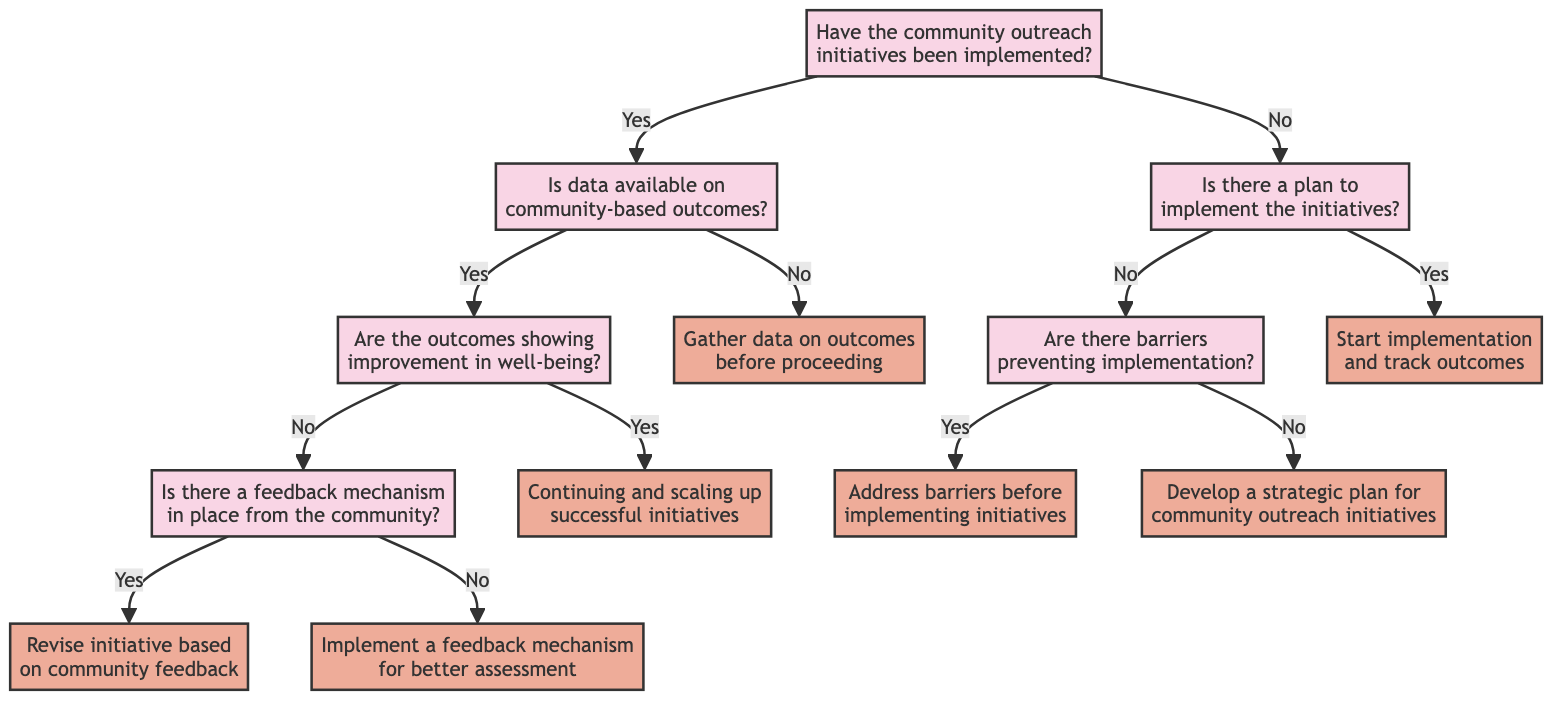What is the first question asked in the decision tree? The first question in the decision tree is "Have the community outreach initiatives been implemented?" which is the starting point of the flow.
Answer: Have the community outreach initiatives been implemented? How many endpoints are there in the decision tree? By examining the diagram, we see there are six endpoints: "Continuing and scaling up successful initiatives," "Revise initiative based on community feedback," "Implement a feedback mechanism for better assessment," "Gather data on outcomes before proceeding," "Start implementation and track outcomes," and "Address barriers before implementing initiatives." Counting them gives a total of six.
Answer: Six What happens if the community outreach initiatives have not been implemented? If the community outreach initiatives have not been implemented, the next question asked is "Is there a plan to implement the initiatives?" leading to further pathways based on the answer.
Answer: Is there a plan to implement the initiatives? If there is feedback from the community but outcomes are not improving, what action is suggested? If the feedback mechanism is in place and the outcomes are not showing improvement, the action suggested is to "Revise initiative based on community feedback." This indicates the importance of utilizing community input for improvement.
Answer: Revise initiative based on community feedback What is the outcome if there is no data about community-based outcomes? If there is no data available on community-based outcomes, the decision tree leads directly to the endpoint "Gather data on outcomes before proceeding," indicating the necessity of data collection before further actions can be taken.
Answer: Gather data on outcomes before proceeding What decision follows if outcomes are improving? If the outcomes are showing improvement in well-being, the decision is to "Continue and scale up successful initiatives," suggesting that positive results warrant further investment and expansion of those initiatives.
Answer: Continue and scale up successful initiatives 